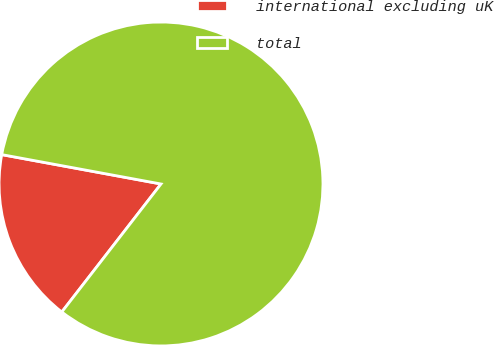Convert chart. <chart><loc_0><loc_0><loc_500><loc_500><pie_chart><fcel>international excluding uK<fcel>total<nl><fcel>17.41%<fcel>82.59%<nl></chart> 